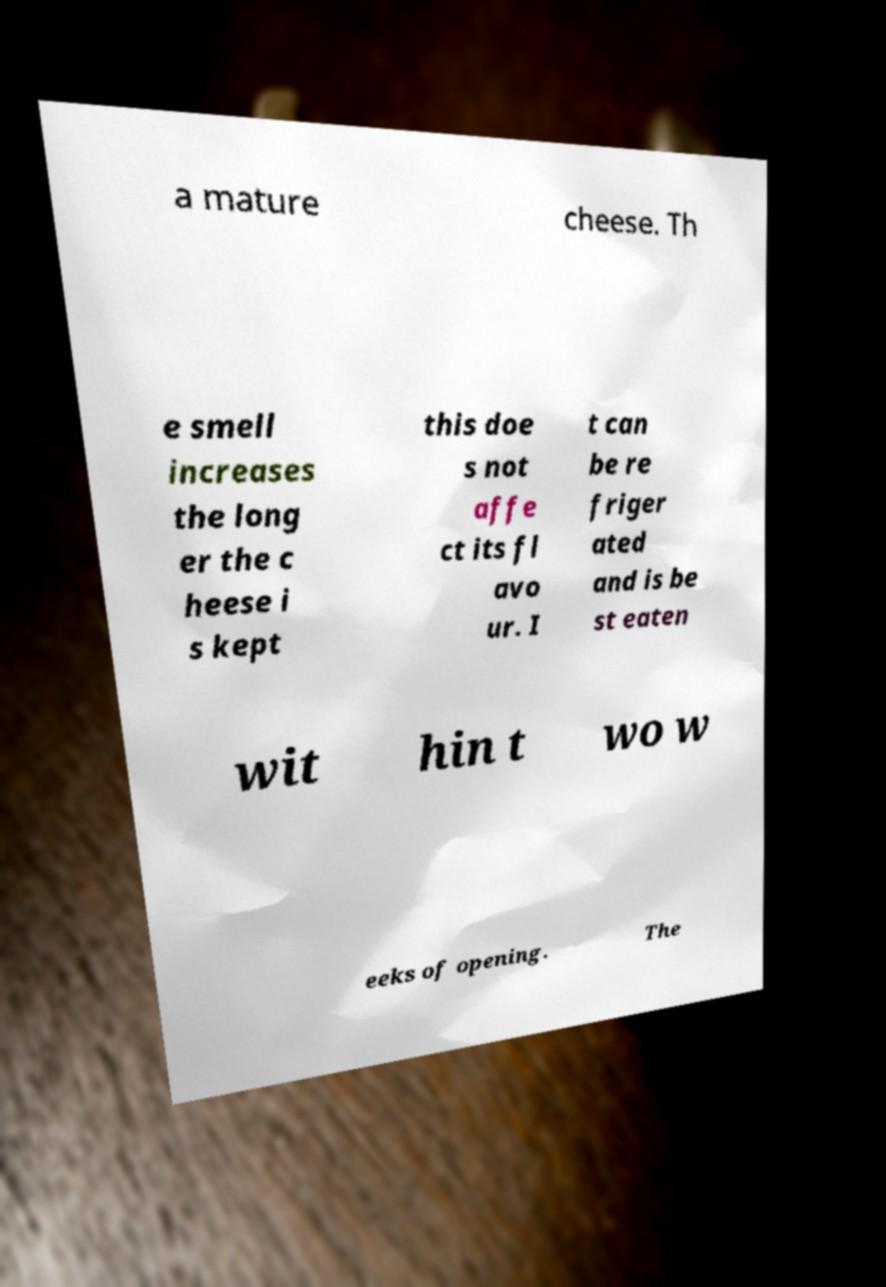Please identify and transcribe the text found in this image. a mature cheese. Th e smell increases the long er the c heese i s kept this doe s not affe ct its fl avo ur. I t can be re friger ated and is be st eaten wit hin t wo w eeks of opening. The 